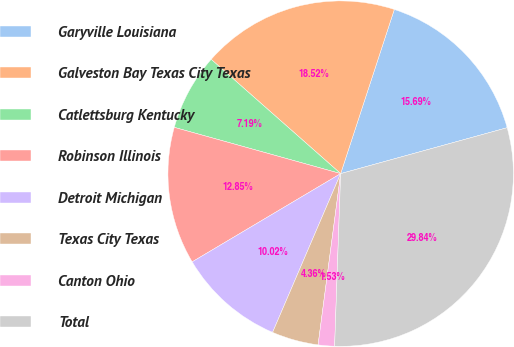Convert chart to OTSL. <chart><loc_0><loc_0><loc_500><loc_500><pie_chart><fcel>Garyville Louisiana<fcel>Galveston Bay Texas City Texas<fcel>Catlettsburg Kentucky<fcel>Robinson Illinois<fcel>Detroit Michigan<fcel>Texas City Texas<fcel>Canton Ohio<fcel>Total<nl><fcel>15.69%<fcel>18.52%<fcel>7.19%<fcel>12.85%<fcel>10.02%<fcel>4.36%<fcel>1.53%<fcel>29.84%<nl></chart> 